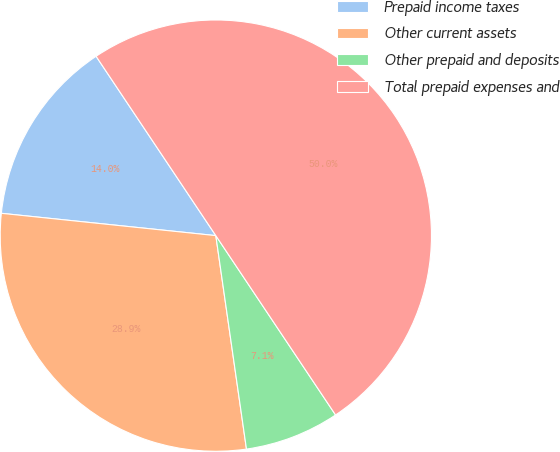Convert chart to OTSL. <chart><loc_0><loc_0><loc_500><loc_500><pie_chart><fcel>Prepaid income taxes<fcel>Other current assets<fcel>Other prepaid and deposits<fcel>Total prepaid expenses and<nl><fcel>13.98%<fcel>28.92%<fcel>7.1%<fcel>50.0%<nl></chart> 